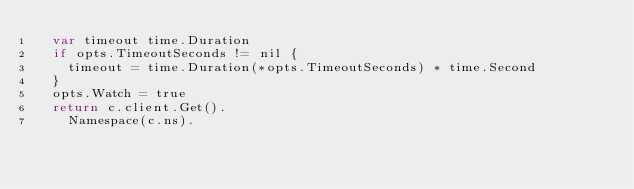<code> <loc_0><loc_0><loc_500><loc_500><_Go_>	var timeout time.Duration
	if opts.TimeoutSeconds != nil {
		timeout = time.Duration(*opts.TimeoutSeconds) * time.Second
	}
	opts.Watch = true
	return c.client.Get().
		Namespace(c.ns).</code> 